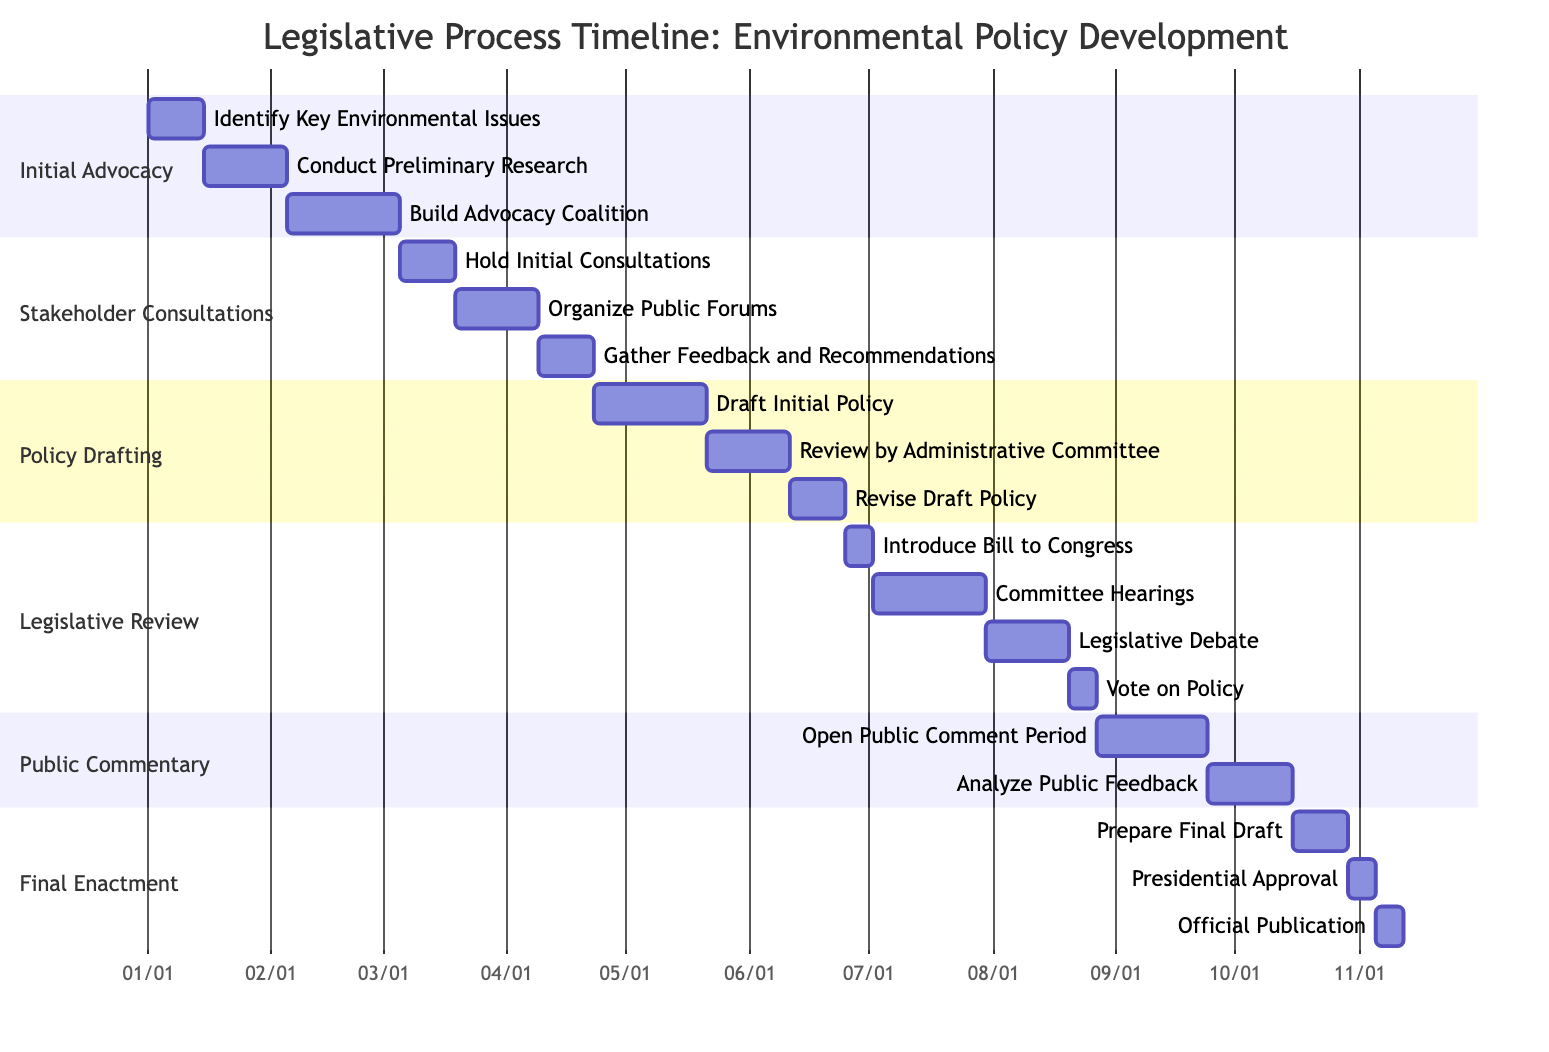What is the duration of the “Initial Advocacy” phase? The “Initial Advocacy” phase includes three tasks: "Identify Key Environmental Issues" (2 weeks), "Conduct Preliminary Research" (3 weeks), and "Build Advocacy Coalition" (4 weeks). Summing these durations gives 2 + 3 + 4, which equals 9 weeks.
Answer: 9 weeks Who are the participants in “Draft Initial Policy”? The task "Draft Initial Policy" is part of the “Policy Drafting” phase and involves participants from two groups: "Government Legislators" and "Environmental Experts".
Answer: Government Legislators, Environmental Experts How many weeks does the “Legislative Review” take? The “Legislative Review” phase consists of four tasks: "Introduce Bill to Congress" (1 week), "Committee Hearings" (4 weeks), "Legislative Debate" (3 weeks), and "Vote on Policy" (1 week). Summing these durations gives 1 + 4 + 3 + 1, which totals to 9 weeks.
Answer: 9 weeks What task follows “Gather Feedback and Recommendations”? The task “Gather Feedback and Recommendations” is the last task in the “Stakeholder Consultations” phase, and the next phase is "Policy Drafting", which begins with the task "Draft Initial Policy".
Answer: Draft Initial Policy Which phase has the longest single task duration? Analyzing the task durations across all phases, "Committee Hearings" in the “Legislative Review” phase has the longest single duration at 4 weeks.
Answer: Committee Hearings What is the total duration of the “Public Commentary” phase? The “Public Commentary” phase contains two tasks: "Open Public Comment Period" (4 weeks) and "Analyze Public Feedback" (3 weeks). Adding these durations gives a total of 4 + 3, equaling 7 weeks.
Answer: 7 weeks During which phase does "Presidential Approval" occur? The task "Presidential Approval" occurs in the final phase, which is "Final Enactment".
Answer: Final Enactment 